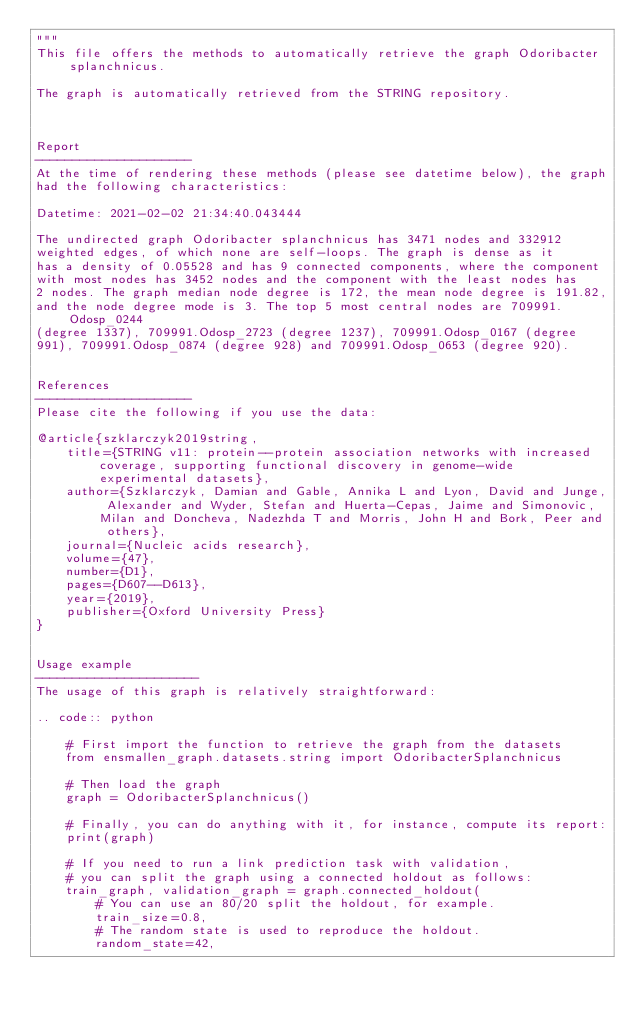Convert code to text. <code><loc_0><loc_0><loc_500><loc_500><_Python_>"""
This file offers the methods to automatically retrieve the graph Odoribacter splanchnicus.

The graph is automatically retrieved from the STRING repository. 



Report
---------------------
At the time of rendering these methods (please see datetime below), the graph
had the following characteristics:

Datetime: 2021-02-02 21:34:40.043444

The undirected graph Odoribacter splanchnicus has 3471 nodes and 332912
weighted edges, of which none are self-loops. The graph is dense as it
has a density of 0.05528 and has 9 connected components, where the component
with most nodes has 3452 nodes and the component with the least nodes has
2 nodes. The graph median node degree is 172, the mean node degree is 191.82,
and the node degree mode is 3. The top 5 most central nodes are 709991.Odosp_0244
(degree 1337), 709991.Odosp_2723 (degree 1237), 709991.Odosp_0167 (degree
991), 709991.Odosp_0874 (degree 928) and 709991.Odosp_0653 (degree 920).


References
---------------------
Please cite the following if you use the data:

@article{szklarczyk2019string,
    title={STRING v11: protein--protein association networks with increased coverage, supporting functional discovery in genome-wide experimental datasets},
    author={Szklarczyk, Damian and Gable, Annika L and Lyon, David and Junge, Alexander and Wyder, Stefan and Huerta-Cepas, Jaime and Simonovic, Milan and Doncheva, Nadezhda T and Morris, John H and Bork, Peer and others},
    journal={Nucleic acids research},
    volume={47},
    number={D1},
    pages={D607--D613},
    year={2019},
    publisher={Oxford University Press}
}


Usage example
----------------------
The usage of this graph is relatively straightforward:

.. code:: python

    # First import the function to retrieve the graph from the datasets
    from ensmallen_graph.datasets.string import OdoribacterSplanchnicus

    # Then load the graph
    graph = OdoribacterSplanchnicus()

    # Finally, you can do anything with it, for instance, compute its report:
    print(graph)

    # If you need to run a link prediction task with validation,
    # you can split the graph using a connected holdout as follows:
    train_graph, validation_graph = graph.connected_holdout(
        # You can use an 80/20 split the holdout, for example.
        train_size=0.8,
        # The random state is used to reproduce the holdout.
        random_state=42,</code> 